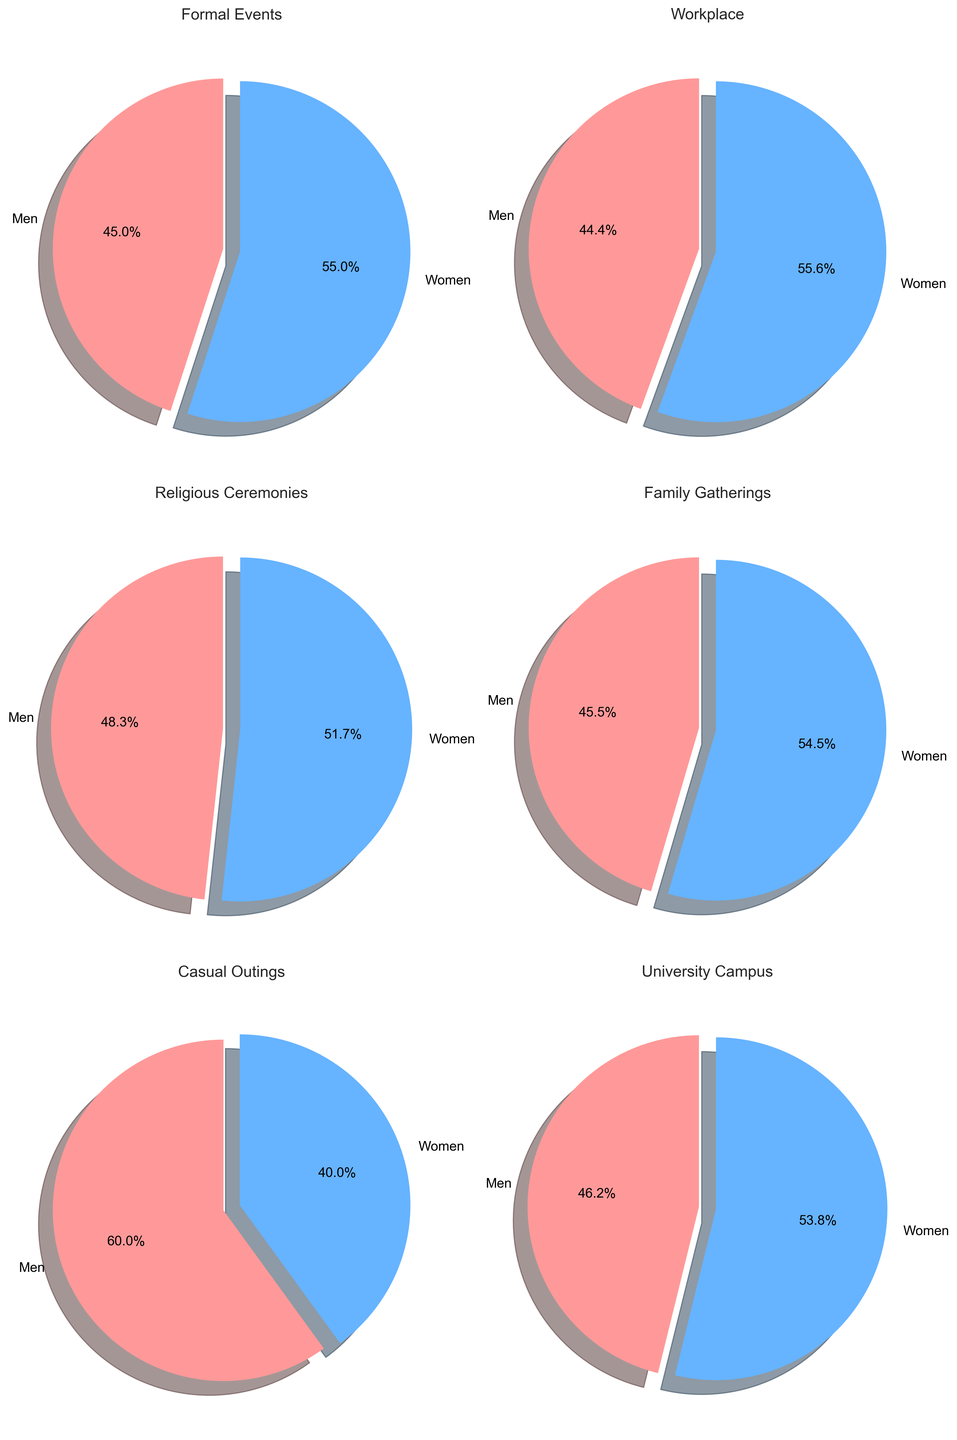What is the percentage difference between men and women wearing cultural attire at formal events? To find the percentage difference between men and women wearing cultural attire at formal events, subtract the percentage for men from the percentage for women: 55% - 45% = 10%.
Answer: 10% Which gender wears cultural attire more frequently at religious ceremonies? To determine which gender wears cultural attire more frequently at religious ceremonies, compare the percentages: 70% for men and 75% for women. Since 75% > 70%, women wear cultural attire more frequently at religious ceremonies.
Answer: Women What is the total percentage of both men and women wearing cultural attire in the workplace? To find the total percentage of both men and women wearing cultural attire in the workplace, sum the percentages for men and women: 20% + 25% = 45%.
Answer: 45% In which social setting is the difference between men and women wearing cultural attire the greatest? To find the largest difference, compare the percentage differences for each setting: Formal Events (10%), Workplace (5%), Religious Ceremonies (5%), Family Gatherings (10%), Casual Outings (5%), University Campus (5%). All these differences are equal, so the largest difference is 10%.
Answer: Formal Events and Family Gatherings Which social setting has the lowest combined percentage of men and women wearing cultural attire? To find this, sum the percentages for men and women in each setting: Formal Events (100%), Workplace (45%), Religious Ceremonies (145%), Family Gatherings (110%), Casual Outings (25%), University Campus (65%). The lowest combined percentage is for Casual Outings, which has 25%.
Answer: Casual Outings 